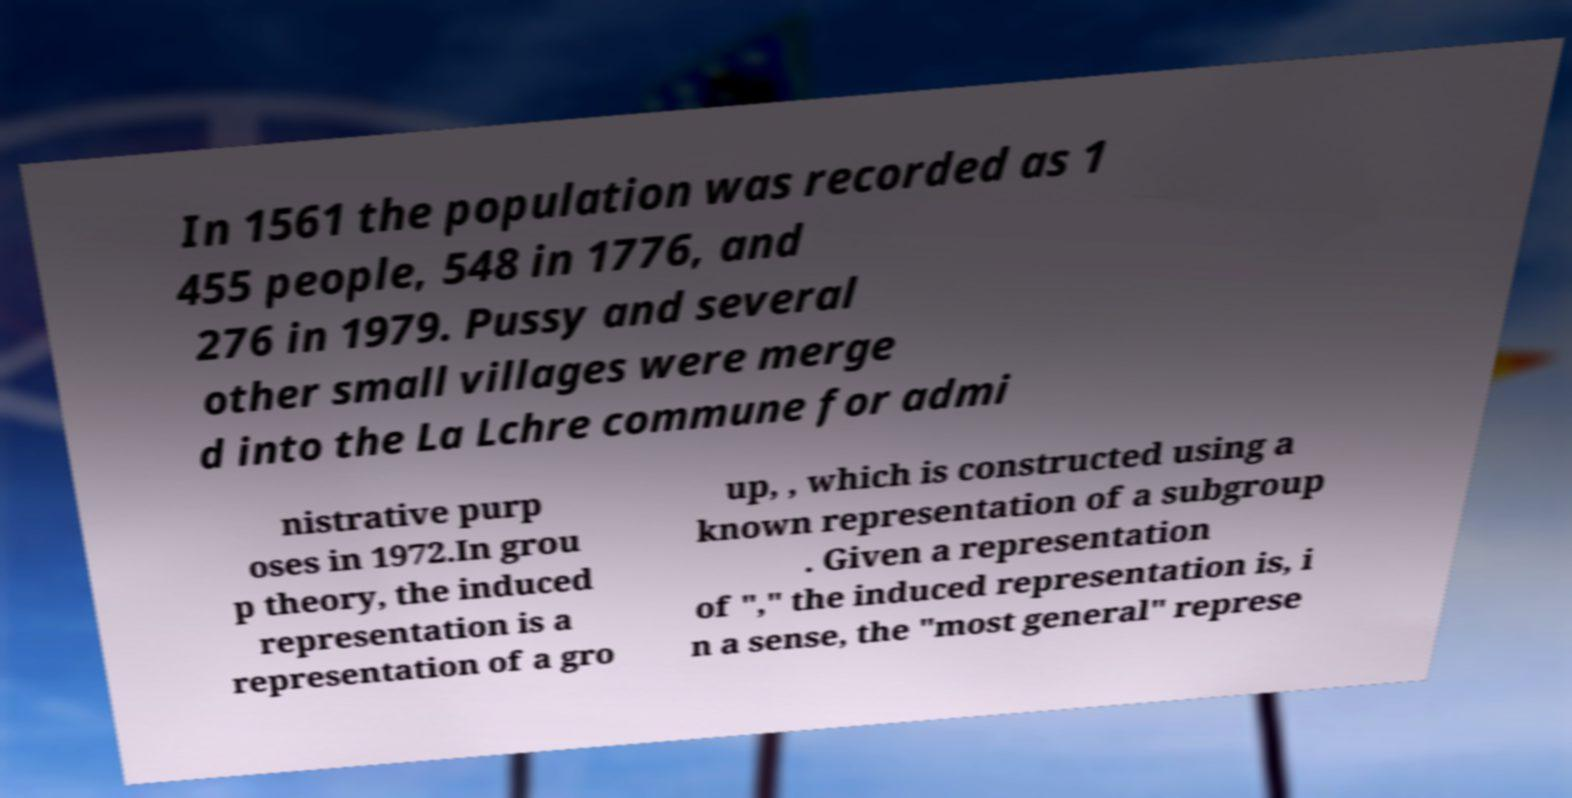Can you read and provide the text displayed in the image?This photo seems to have some interesting text. Can you extract and type it out for me? In 1561 the population was recorded as 1 455 people, 548 in 1776, and 276 in 1979. Pussy and several other small villages were merge d into the La Lchre commune for admi nistrative purp oses in 1972.In grou p theory, the induced representation is a representation of a gro up, , which is constructed using a known representation of a subgroup . Given a representation of "," the induced representation is, i n a sense, the "most general" represe 